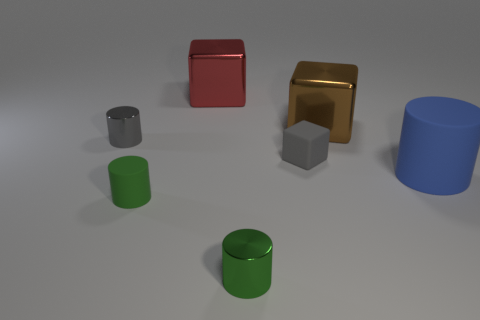Add 2 big brown shiny blocks. How many objects exist? 9 Subtract all cylinders. How many objects are left? 3 Add 2 brown things. How many brown things exist? 3 Subtract 0 purple cubes. How many objects are left? 7 Subtract all large metallic things. Subtract all small red cubes. How many objects are left? 5 Add 6 cylinders. How many cylinders are left? 10 